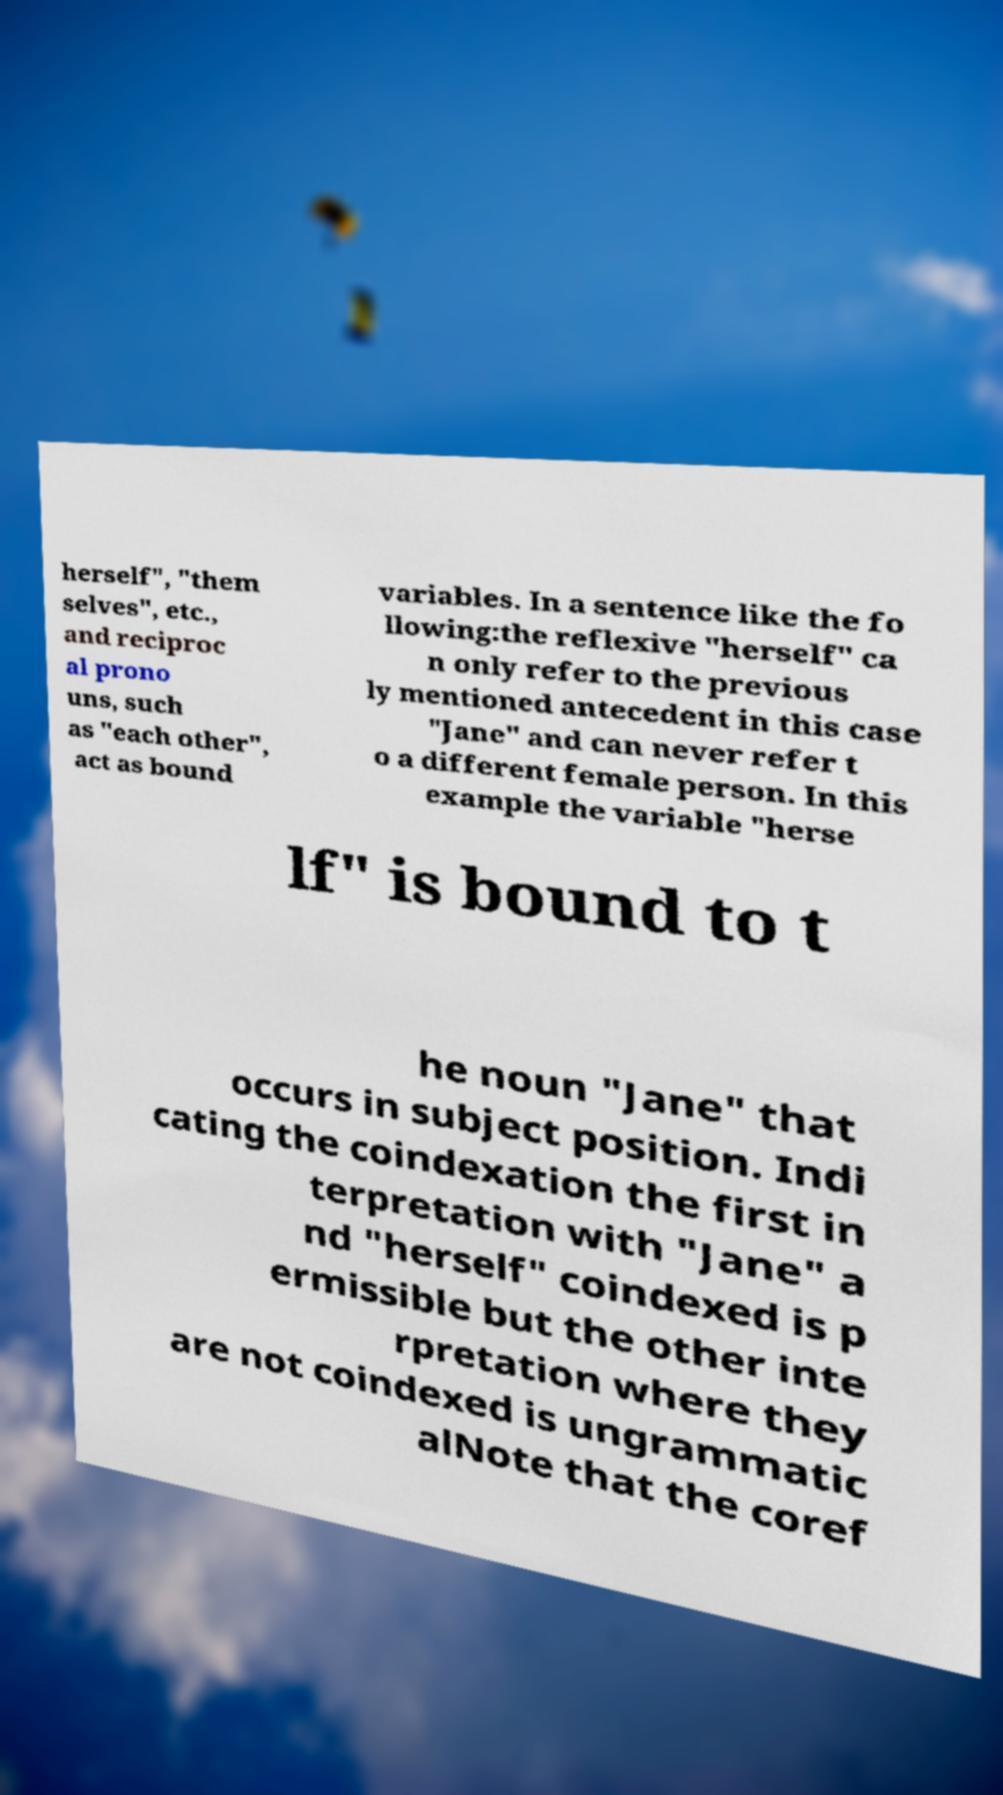Could you extract and type out the text from this image? herself", "them selves", etc., and reciproc al prono uns, such as "each other", act as bound variables. In a sentence like the fo llowing:the reflexive "herself" ca n only refer to the previous ly mentioned antecedent in this case "Jane" and can never refer t o a different female person. In this example the variable "herse lf" is bound to t he noun "Jane" that occurs in subject position. Indi cating the coindexation the first in terpretation with "Jane" a nd "herself" coindexed is p ermissible but the other inte rpretation where they are not coindexed is ungrammatic alNote that the coref 